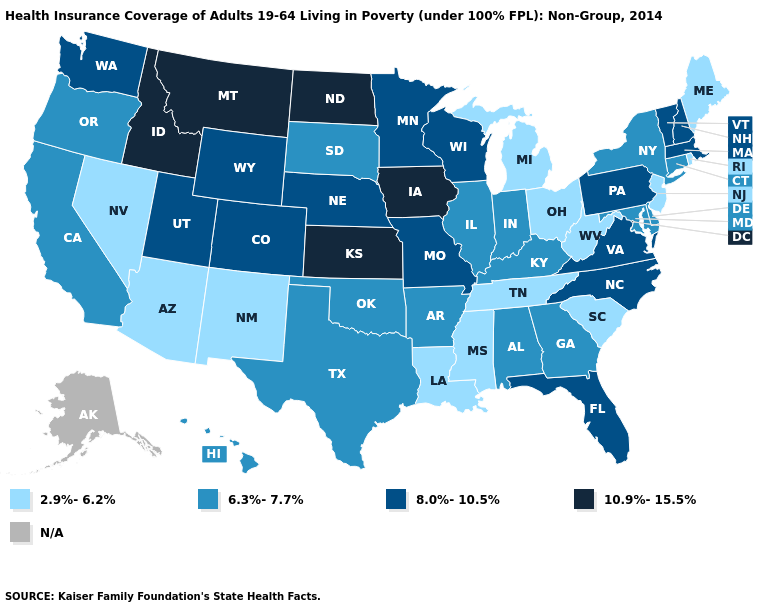Name the states that have a value in the range 6.3%-7.7%?
Answer briefly. Alabama, Arkansas, California, Connecticut, Delaware, Georgia, Hawaii, Illinois, Indiana, Kentucky, Maryland, New York, Oklahoma, Oregon, South Dakota, Texas. Does Connecticut have the highest value in the Northeast?
Write a very short answer. No. What is the value of Idaho?
Concise answer only. 10.9%-15.5%. Name the states that have a value in the range 6.3%-7.7%?
Be succinct. Alabama, Arkansas, California, Connecticut, Delaware, Georgia, Hawaii, Illinois, Indiana, Kentucky, Maryland, New York, Oklahoma, Oregon, South Dakota, Texas. Does Louisiana have the lowest value in the USA?
Quick response, please. Yes. Name the states that have a value in the range 10.9%-15.5%?
Give a very brief answer. Idaho, Iowa, Kansas, Montana, North Dakota. How many symbols are there in the legend?
Answer briefly. 5. What is the lowest value in the West?
Short answer required. 2.9%-6.2%. Which states have the lowest value in the Northeast?
Concise answer only. Maine, New Jersey, Rhode Island. Among the states that border Idaho , which have the lowest value?
Be succinct. Nevada. What is the value of Mississippi?
Quick response, please. 2.9%-6.2%. Which states hav the highest value in the West?
Quick response, please. Idaho, Montana. What is the highest value in the West ?
Short answer required. 10.9%-15.5%. What is the lowest value in the USA?
Answer briefly. 2.9%-6.2%. 